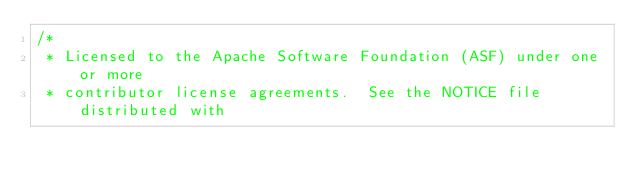<code> <loc_0><loc_0><loc_500><loc_500><_Scala_>/*
 * Licensed to the Apache Software Foundation (ASF) under one or more
 * contributor license agreements.  See the NOTICE file distributed with</code> 